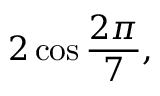Convert formula to latex. <formula><loc_0><loc_0><loc_500><loc_500>2 \cos { \frac { 2 \pi } { 7 } } ,</formula> 